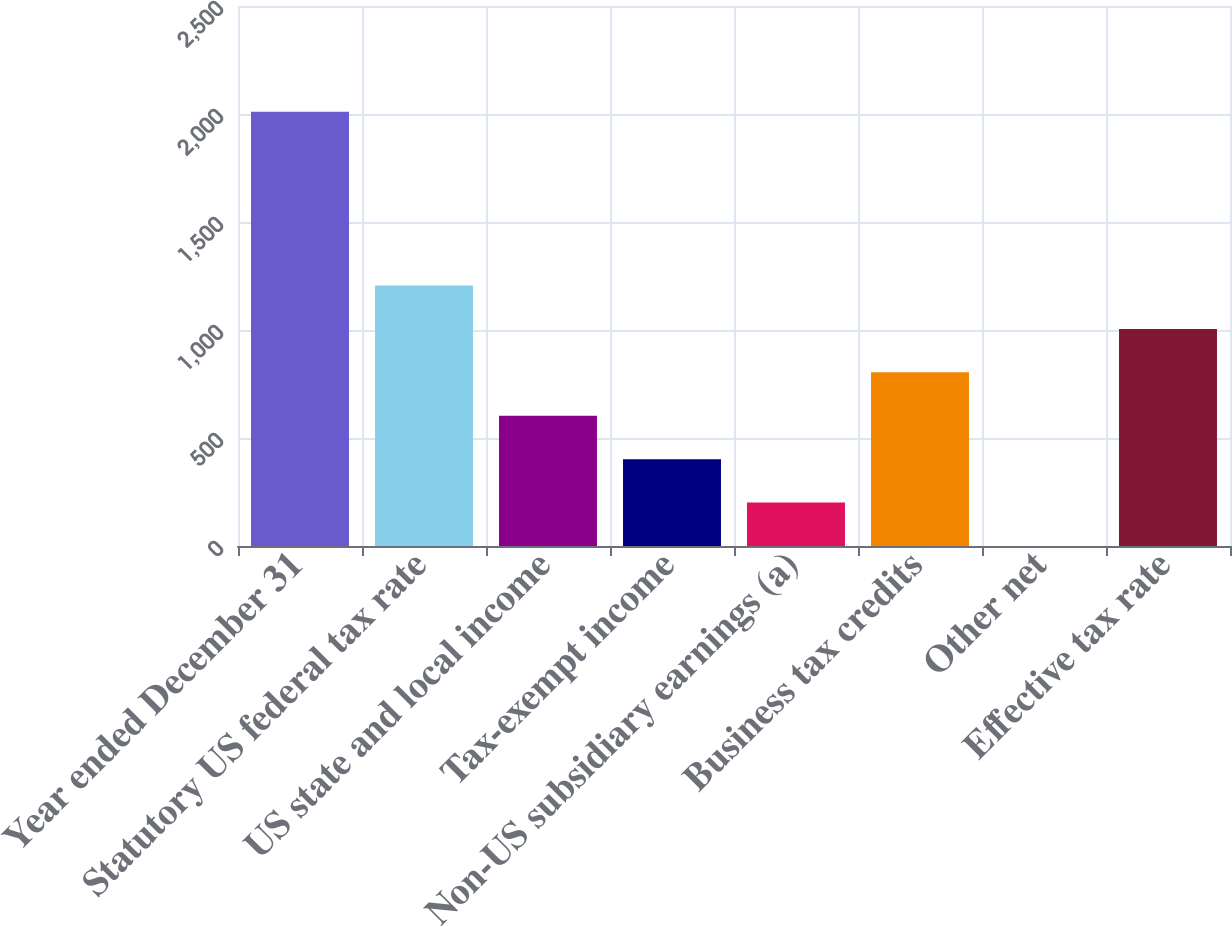Convert chart. <chart><loc_0><loc_0><loc_500><loc_500><bar_chart><fcel>Year ended December 31<fcel>Statutory US federal tax rate<fcel>US state and local income<fcel>Tax-exempt income<fcel>Non-US subsidiary earnings (a)<fcel>Business tax credits<fcel>Other net<fcel>Effective tax rate<nl><fcel>2010<fcel>1206.08<fcel>603.14<fcel>402.16<fcel>201.18<fcel>804.12<fcel>0.2<fcel>1005.1<nl></chart> 